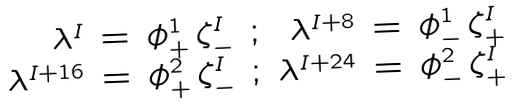Convert formula to latex. <formula><loc_0><loc_0><loc_500><loc_500>\begin{array} { r c l c r c l } \lambda ^ { I } & = & \phi _ { + } ^ { 1 } \, \zeta _ { - } ^ { I } & ; & \lambda ^ { I + 8 } & = & \phi _ { - } ^ { 1 } \, \zeta _ { + } ^ { I } \\ \lambda ^ { I + 1 6 } & = & \phi _ { + } ^ { 2 } \, \zeta _ { - } ^ { I } & ; & \lambda ^ { I + 2 4 } & = & \phi _ { - } ^ { 2 } \, \zeta _ { + } ^ { I } \end{array}</formula> 